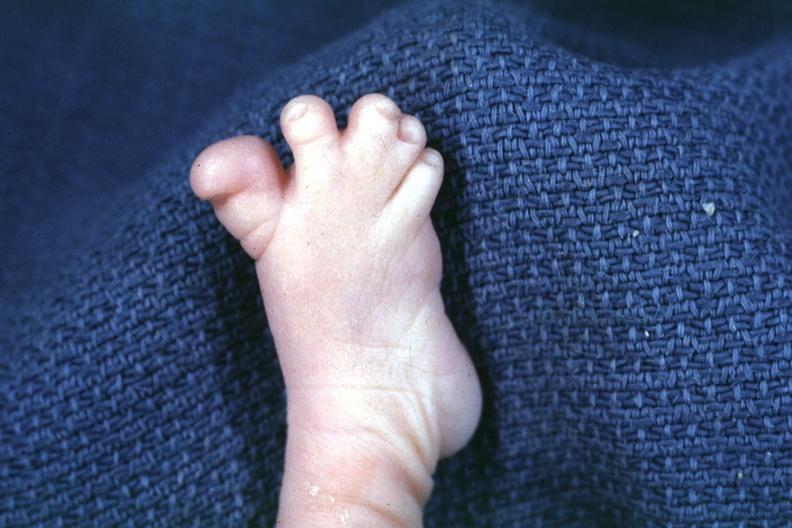what is present?
Answer the question using a single word or phrase. Foot 